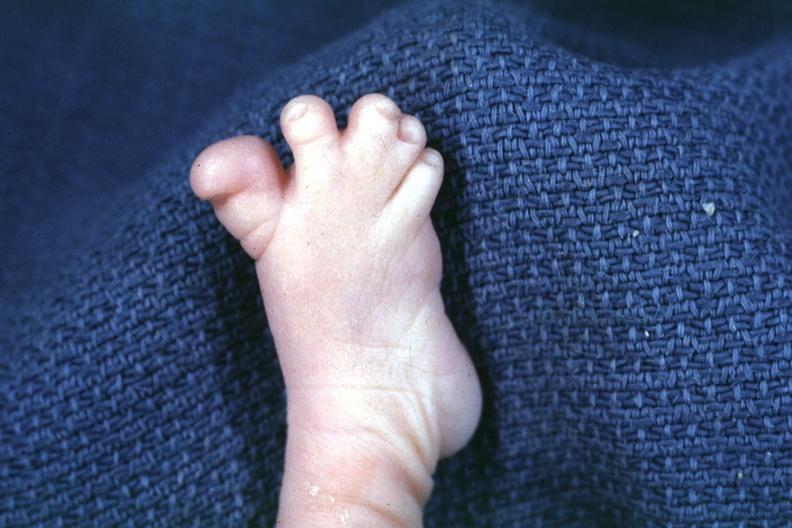what is present?
Answer the question using a single word or phrase. Foot 